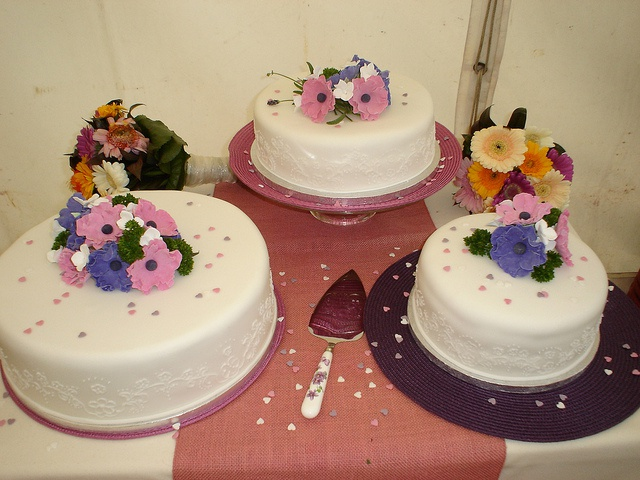Describe the objects in this image and their specific colors. I can see dining table in tan, brown, salmon, and maroon tones, cake in tan and beige tones, cake in tan, darkgray, and beige tones, cake in tan, beige, and brown tones, and knife in tan, maroon, brown, and beige tones in this image. 